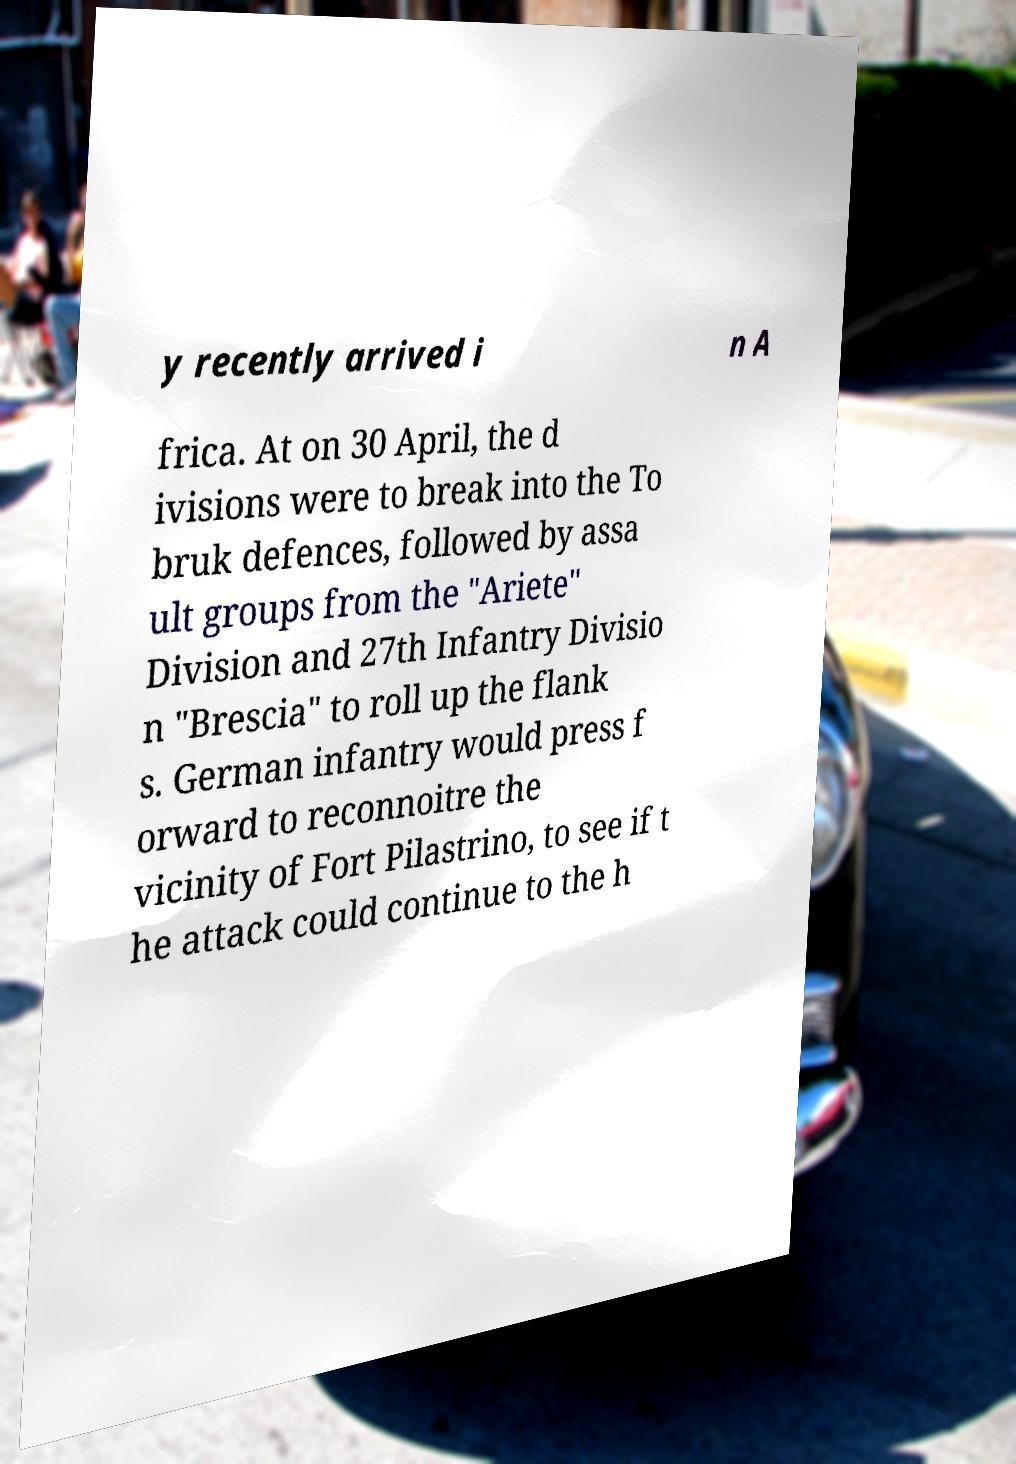What messages or text are displayed in this image? I need them in a readable, typed format. y recently arrived i n A frica. At on 30 April, the d ivisions were to break into the To bruk defences, followed by assa ult groups from the "Ariete" Division and 27th Infantry Divisio n "Brescia" to roll up the flank s. German infantry would press f orward to reconnoitre the vicinity of Fort Pilastrino, to see if t he attack could continue to the h 